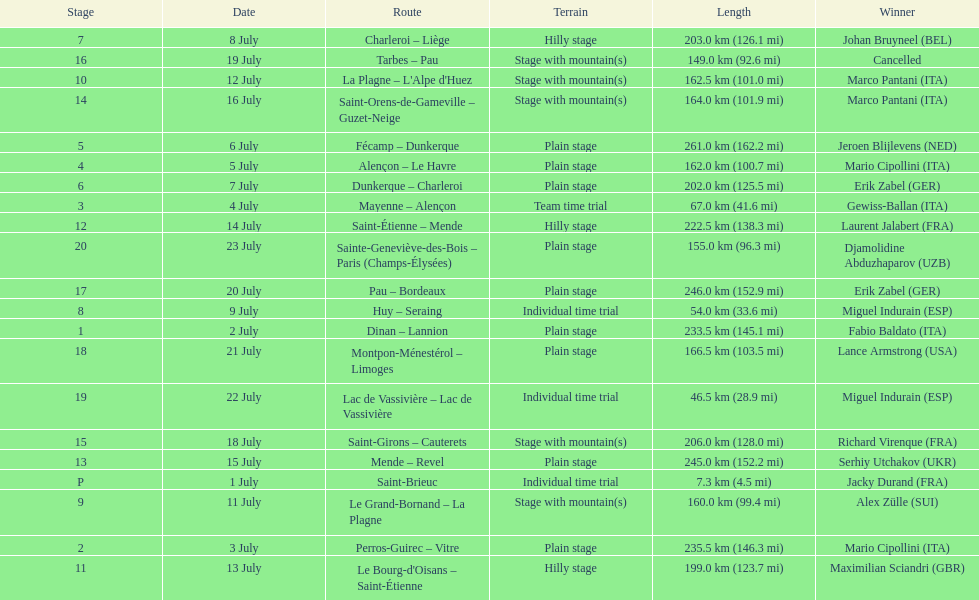How many consecutive km were raced on july 8th? 203.0 km (126.1 mi). 